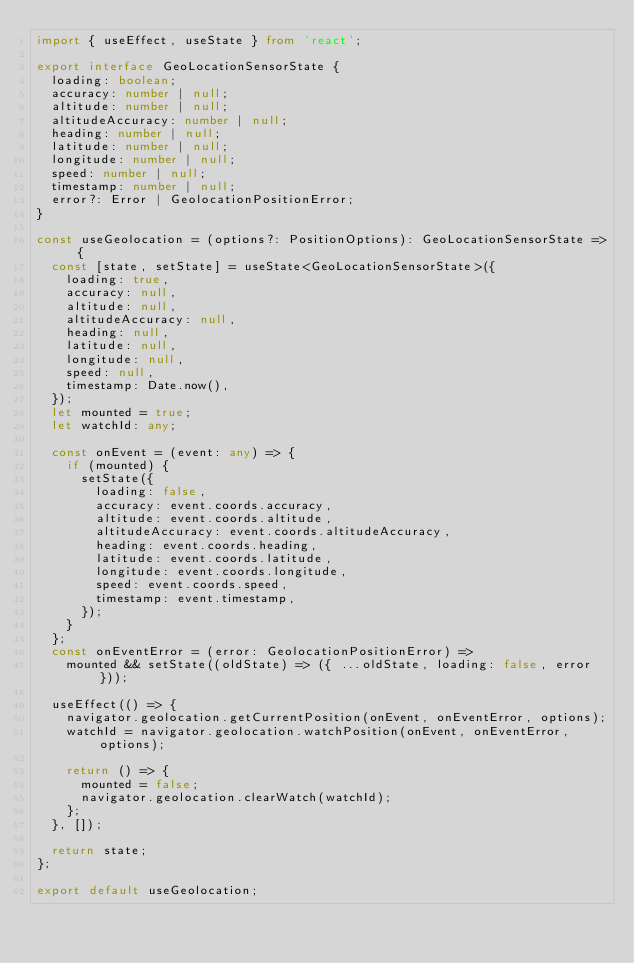<code> <loc_0><loc_0><loc_500><loc_500><_TypeScript_>import { useEffect, useState } from 'react';

export interface GeoLocationSensorState {
  loading: boolean;
  accuracy: number | null;
  altitude: number | null;
  altitudeAccuracy: number | null;
  heading: number | null;
  latitude: number | null;
  longitude: number | null;
  speed: number | null;
  timestamp: number | null;
  error?: Error | GeolocationPositionError;
}

const useGeolocation = (options?: PositionOptions): GeoLocationSensorState => {
  const [state, setState] = useState<GeoLocationSensorState>({
    loading: true,
    accuracy: null,
    altitude: null,
    altitudeAccuracy: null,
    heading: null,
    latitude: null,
    longitude: null,
    speed: null,
    timestamp: Date.now(),
  });
  let mounted = true;
  let watchId: any;

  const onEvent = (event: any) => {
    if (mounted) {
      setState({
        loading: false,
        accuracy: event.coords.accuracy,
        altitude: event.coords.altitude,
        altitudeAccuracy: event.coords.altitudeAccuracy,
        heading: event.coords.heading,
        latitude: event.coords.latitude,
        longitude: event.coords.longitude,
        speed: event.coords.speed,
        timestamp: event.timestamp,
      });
    }
  };
  const onEventError = (error: GeolocationPositionError) =>
    mounted && setState((oldState) => ({ ...oldState, loading: false, error }));

  useEffect(() => {
    navigator.geolocation.getCurrentPosition(onEvent, onEventError, options);
    watchId = navigator.geolocation.watchPosition(onEvent, onEventError, options);

    return () => {
      mounted = false;
      navigator.geolocation.clearWatch(watchId);
    };
  }, []);

  return state;
};

export default useGeolocation;
</code> 